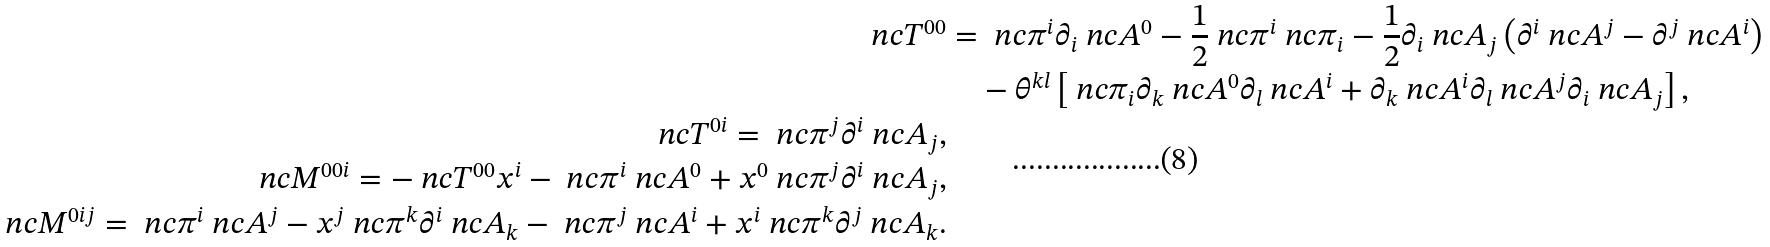Convert formula to latex. <formula><loc_0><loc_0><loc_500><loc_500>\ n c { T } ^ { 0 0 } & = \ n c { \pi } ^ { i } \partial _ { i } \ n c { A } ^ { 0 } - \frac { 1 } { 2 } \ n c { \pi } ^ { i } \ n c { \pi } _ { i } - \frac { 1 } { 2 } \partial _ { i } \ n c { A } _ { j } \left ( \partial ^ { i } \ n c { A } ^ { j } - \partial ^ { j } \ n c { A } ^ { i } \right ) \\ & \quad - \theta ^ { k l } \left [ \ n c { \pi } _ { i } \partial _ { k } \ n c { A } ^ { 0 } \partial _ { l } \ n c { A } ^ { i } + \partial _ { k } \ n c { A } ^ { i } \partial _ { l } \ n c { A } ^ { j } \partial _ { i } \ n c { A } _ { j } \right ] , \\ \ n c { T } ^ { 0 i } = \ n c { \pi } ^ { j } \partial ^ { i } \ n c { A } _ { j } , \\ \ n c { M } ^ { 0 0 i } = - \ n c { T } ^ { 0 0 } x ^ { i } - \ n c { \pi } ^ { i } \ n c { A } ^ { 0 } + x ^ { 0 } \ n c { \pi } ^ { j } \partial ^ { i } \ n c { A } _ { j } , \\ \ n c { M } ^ { 0 i j } = \ n c { \pi } ^ { i } \ n c { A } ^ { j } - x ^ { j } \ n c { \pi } ^ { k } \partial ^ { i } \ n c { A } _ { k } - \ n c { \pi } ^ { j } \ n c { A } ^ { i } + x ^ { i } \ n c { \pi } ^ { k } \partial ^ { j } \ n c { A } _ { k } .</formula> 